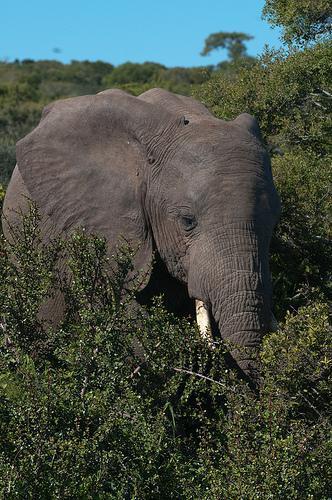How many elephants are there?
Give a very brief answer. 1. 